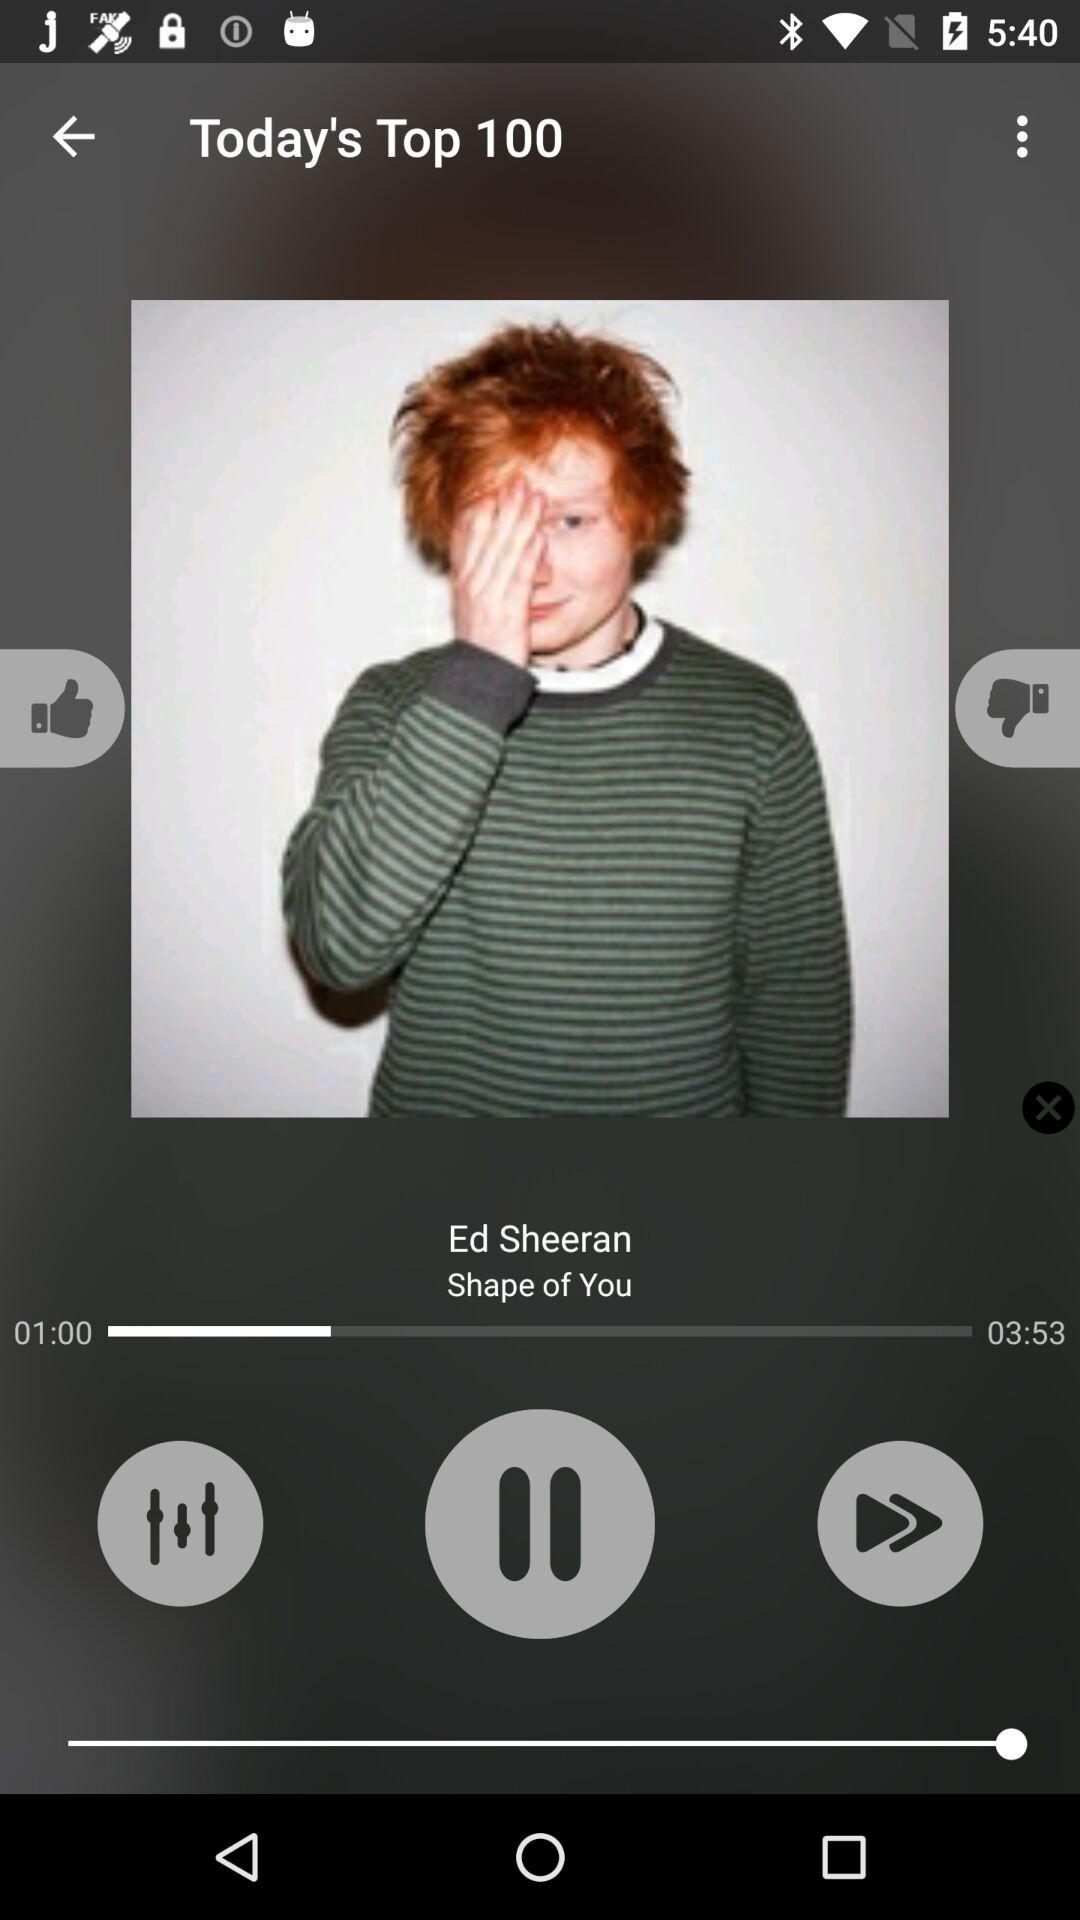What is the duration of the song? The duration of the song is 3 minutes 53 seconds. 